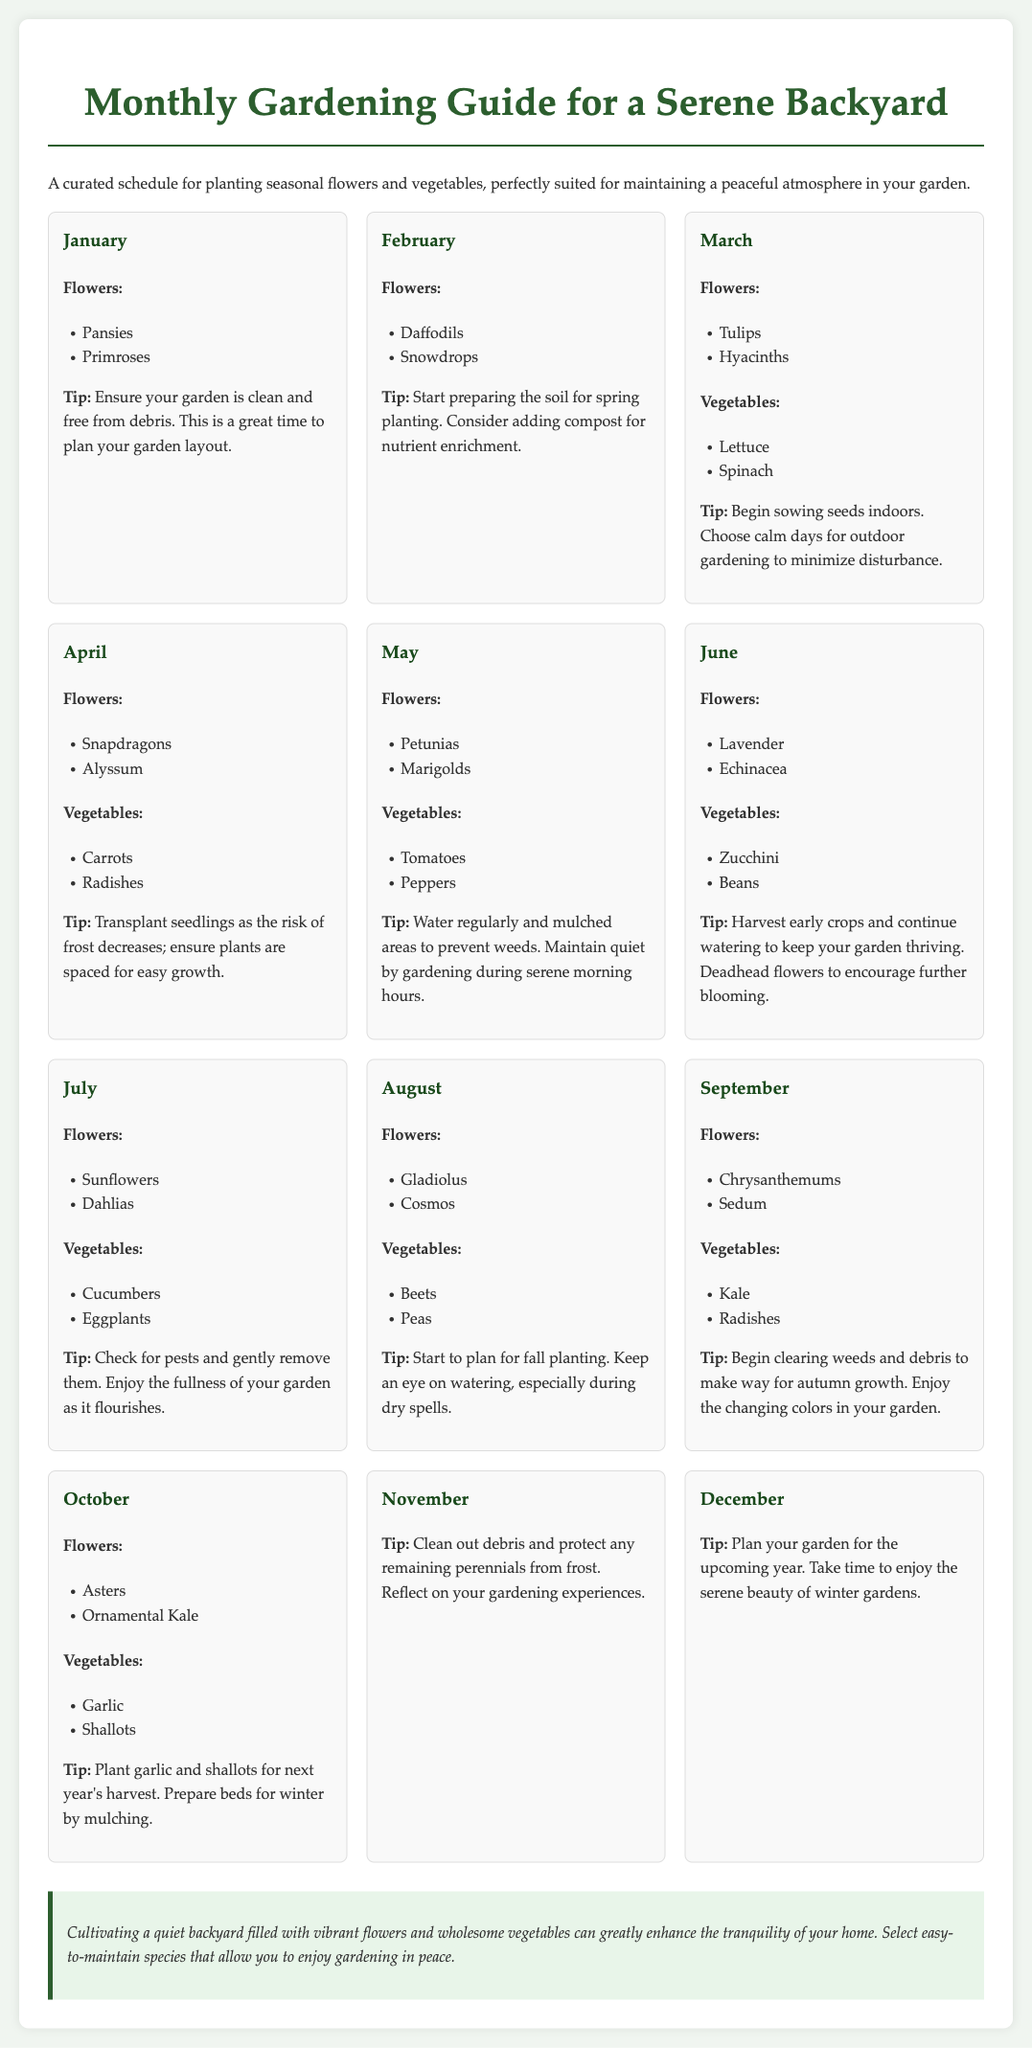What flowers can be planted in January? January features Pansies and Primroses as suitable flowers for planting.
Answer: Pansies, Primroses What vegetables are suggested for planting in April? The recommended vegetables for April are Carrots and Radishes.
Answer: Carrots, Radishes Which month includes the planting of Sunflowers? Sunflowers are to be planted in July, as indicated in the monthly schedule.
Answer: July What is a key tip for May gardening? In May, it is advised to water regularly and mulch areas to prevent weeds, while maintaining quiet morning gardening hours.
Answer: Water regularly and mulch Which two flowers are mentioned for August? August features Gladiolus and Cosmos as suitable flowers for the month.
Answer: Gladiolus, Cosmos How many months suggest cleaning out debris? Both November and December emphasize the importance of cleaning out debris in the garden.
Answer: Two months What is the primary focus of the gardening guide? The guide focuses on creating a serene backyard by providing a gardening schedule for easy maintenance flowers and vegetables.
Answer: Serene backyard What should be prepared in February for spring? The guide suggests preparing the soil for spring planting in February, highlighting the addition of compost.
Answer: Soil preparation 